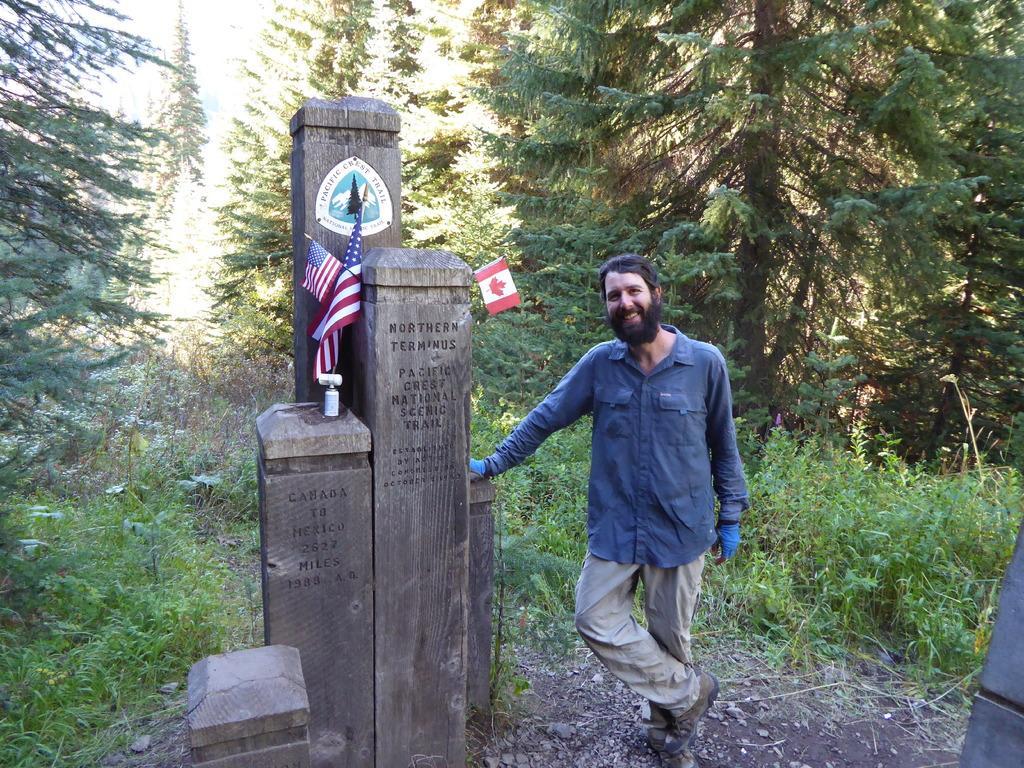How would you summarize this image in a sentence or two? This is the man standing and smiling. These are the flags, which are hanging to the poles. I think these are the stones with the letters carved on it. I can see the trees and plants. 